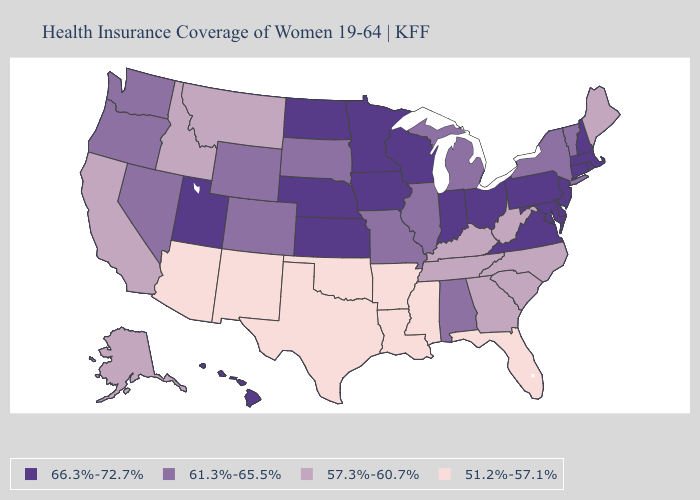Does Kentucky have the highest value in the South?
Answer briefly. No. Does Montana have the highest value in the USA?
Write a very short answer. No. Does Virginia have the same value as Kansas?
Give a very brief answer. Yes. Among the states that border Indiana , does Illinois have the lowest value?
Short answer required. No. What is the highest value in the Northeast ?
Write a very short answer. 66.3%-72.7%. Name the states that have a value in the range 61.3%-65.5%?
Answer briefly. Alabama, Colorado, Illinois, Michigan, Missouri, Nevada, New York, Oregon, South Dakota, Vermont, Washington, Wyoming. What is the value of Massachusetts?
Quick response, please. 66.3%-72.7%. Does Iowa have the same value as Hawaii?
Quick response, please. Yes. Which states have the highest value in the USA?
Concise answer only. Connecticut, Delaware, Hawaii, Indiana, Iowa, Kansas, Maryland, Massachusetts, Minnesota, Nebraska, New Hampshire, New Jersey, North Dakota, Ohio, Pennsylvania, Rhode Island, Utah, Virginia, Wisconsin. Which states hav the highest value in the West?
Be succinct. Hawaii, Utah. What is the value of Maine?
Concise answer only. 57.3%-60.7%. How many symbols are there in the legend?
Write a very short answer. 4. Among the states that border Nevada , which have the lowest value?
Be succinct. Arizona. What is the value of Kansas?
Keep it brief. 66.3%-72.7%. Does Arizona have the lowest value in the West?
Be succinct. Yes. 